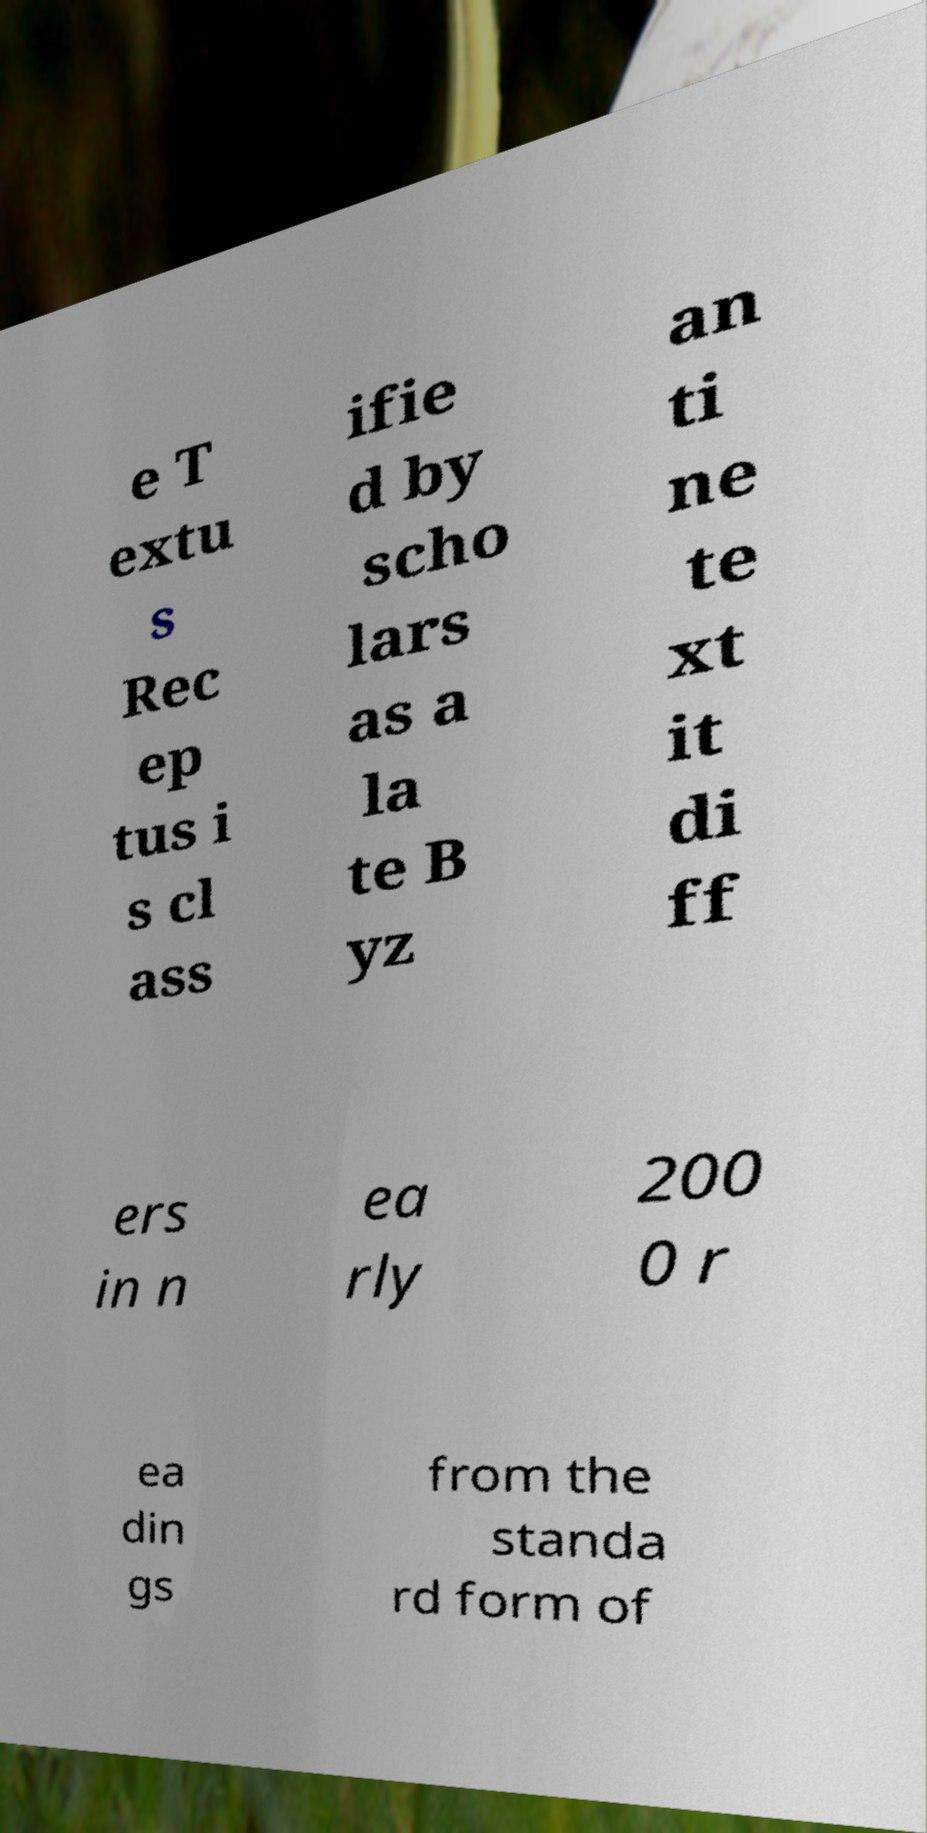What messages or text are displayed in this image? I need them in a readable, typed format. e T extu s Rec ep tus i s cl ass ifie d by scho lars as a la te B yz an ti ne te xt it di ff ers in n ea rly 200 0 r ea din gs from the standa rd form of 